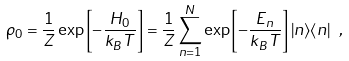<formula> <loc_0><loc_0><loc_500><loc_500>\rho _ { 0 } = \frac { 1 } { Z } \exp \left [ - \frac { H _ { 0 } } { k _ { B } T } \right ] = \frac { 1 } { Z } \sum _ { n = 1 } ^ { N } \exp \left [ - \frac { E _ { n } } { k _ { B } T } \right ] | n \rangle \langle n | \ ,</formula> 